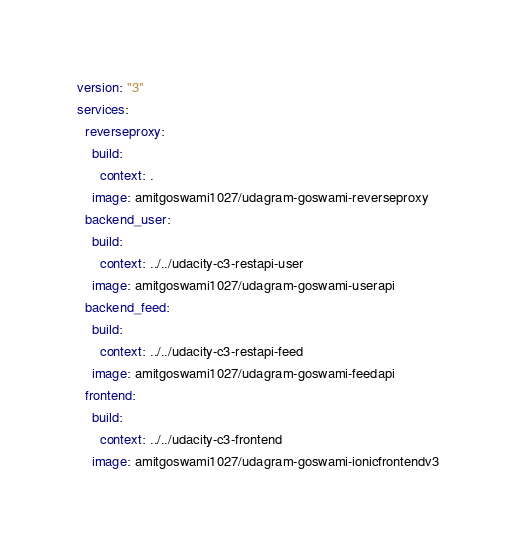<code> <loc_0><loc_0><loc_500><loc_500><_YAML_>version: "3"
services:
  reverseproxy:
    build:
      context: .
    image: amitgoswami1027/udagram-goswami-reverseproxy 
  backend_user:
    build:
      context: ../../udacity-c3-restapi-user
    image: amitgoswami1027/udagram-goswami-userapi
  backend_feed:
    build:
      context: ../../udacity-c3-restapi-feed  
    image: amitgoswami1027/udagram-goswami-feedapi
  frontend:
    build:
      context: ../../udacity-c3-frontend  
    image: amitgoswami1027/udagram-goswami-ionicfrontendv3
</code> 